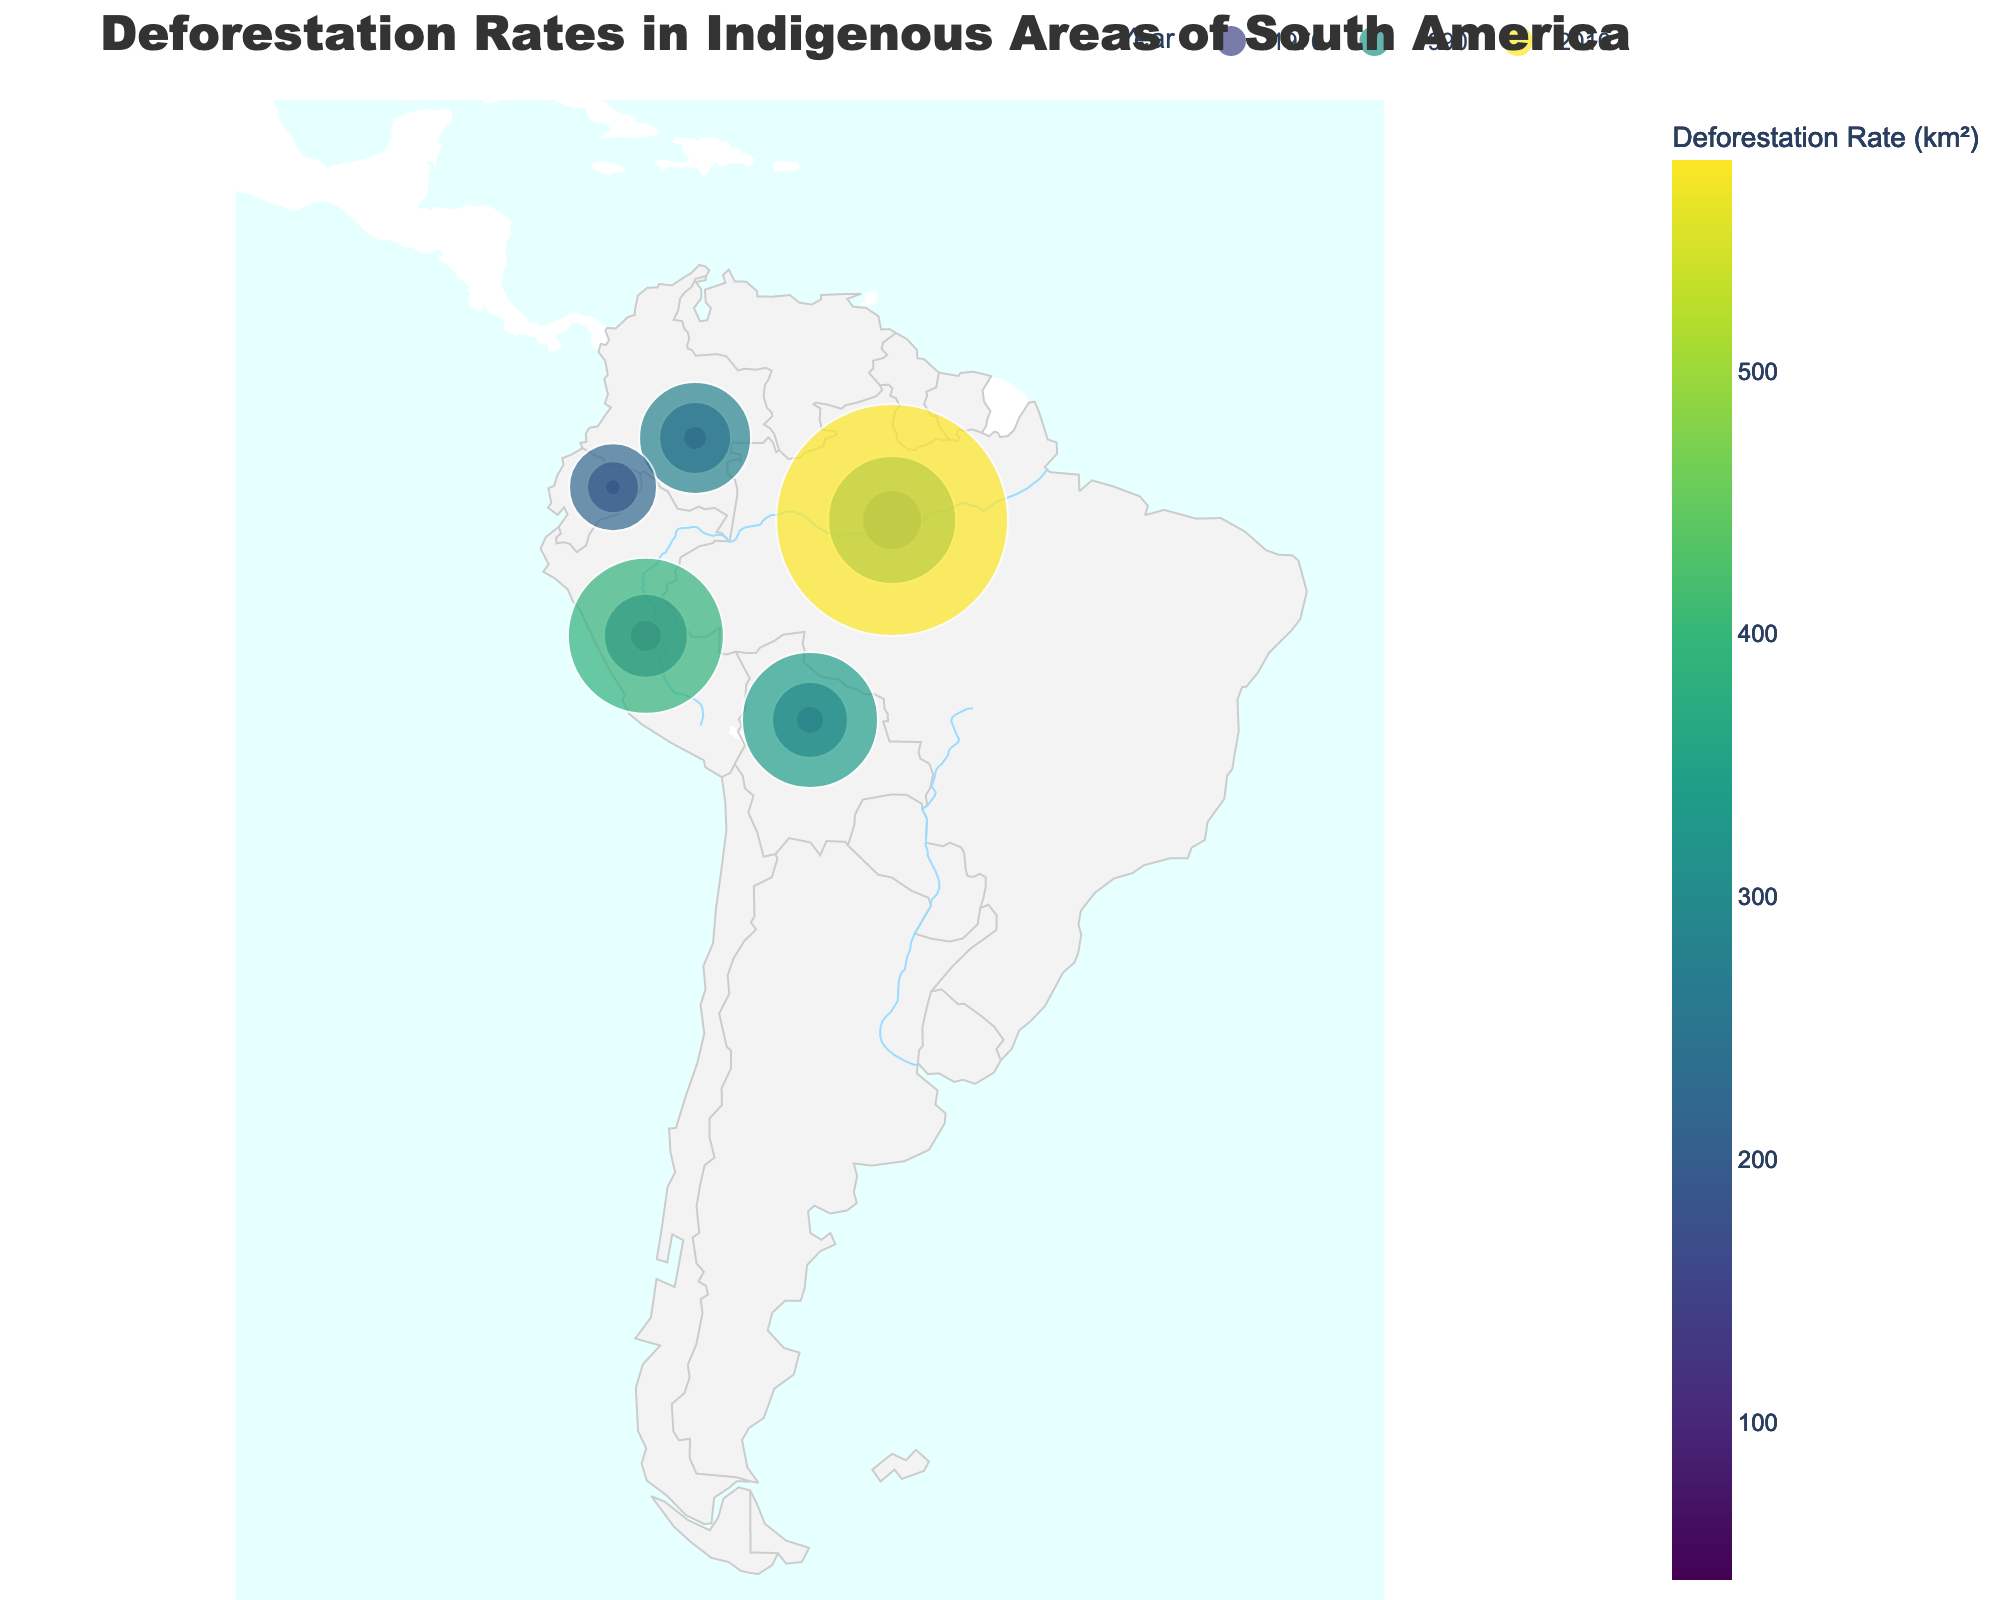Does the rate of deforestation appear to increase, decrease, or remain constant over the years in the Yanomami area? Observing the sequential increase in the size of the markers and the color intensity from 1970, 1990, to 2010, the deforestation rate in the Yanomami area increases over the years.
Answer: Increase Which year had the highest overall deforestation rates across all the indigenous areas? By comparing the marker sizes and color intensities in each year, the year 2010 shows the largest markers and most intense color, indicating the highest deforestation rates.
Answer: 2010 Which indigenous area in Brazil had the deforestation rate in 1990? Locate the corresponding marker for Brazil in 1990 and observe the text label, which indicates the Yanomami area with a deforestation rate of 320 km².
Answer: Yanomami with 320 km² How does the deforestation rate in the Asháninka area in 1990 compare to that in 2010? The deforestation rate in the Asháninka area in 1990 is 210 km², while in 2010 it is 390 km². Thus, the rate in 2010 is nearly double that in 1990.
Answer: Increased significantly, nearly double Which two indigenous areas experienced the smallest deforestation rates in 1970? By reviewing the marker sizes in 1970, the areas with the smallest markers are the Huaorani (40 km²) and Nukak (60 km²) areas.
Answer: Huaorani (40 km²) and Nukak (60 km²) What is the trend of deforestation in the Tsimane area from 1970 to 2010? Observing the markers for the Tsimane area over the years shows an increase in deforestation rates from 70 km² (1970), 190 km² (1990), to 340 km² (2010), indicating a rising trend.
Answer: Rising trend Compare the deforestation rates in the Nukak area between 1990 and 2010. The figure shows the Nukak area having a deforestation rate of 180 km² in 1990 and 280 km² in 2010. The rate increased by 100 km² over these 20 years.
Answer: Increased by 100 km² Which indigenous area in Peru had a deforestation rate of 80 km² in 1970? By locating the marker in Peru for 1970 and reading the label, the Asháninka area had a deforestation rate of 80 km².
Answer: Asháninka How do the deforestation rates in Brazil and Bolivia in 2010 compare? Check the markers for both Brazil (Yanomami, 580 km²) and Bolivia (Tsimane, 340 km²) in 2010 and compare their sizes and color intensities. The rates in Brazil are higher.
Answer: Higher in Brazil (580 km² vs. 340 km²) What is the deforestation rate for the Huaorani area in 1990? By locating the marker in Ecuador for 1990 and referring to the label, the deforestation rate for the Huaorani area is 130 km².
Answer: 130 km² 